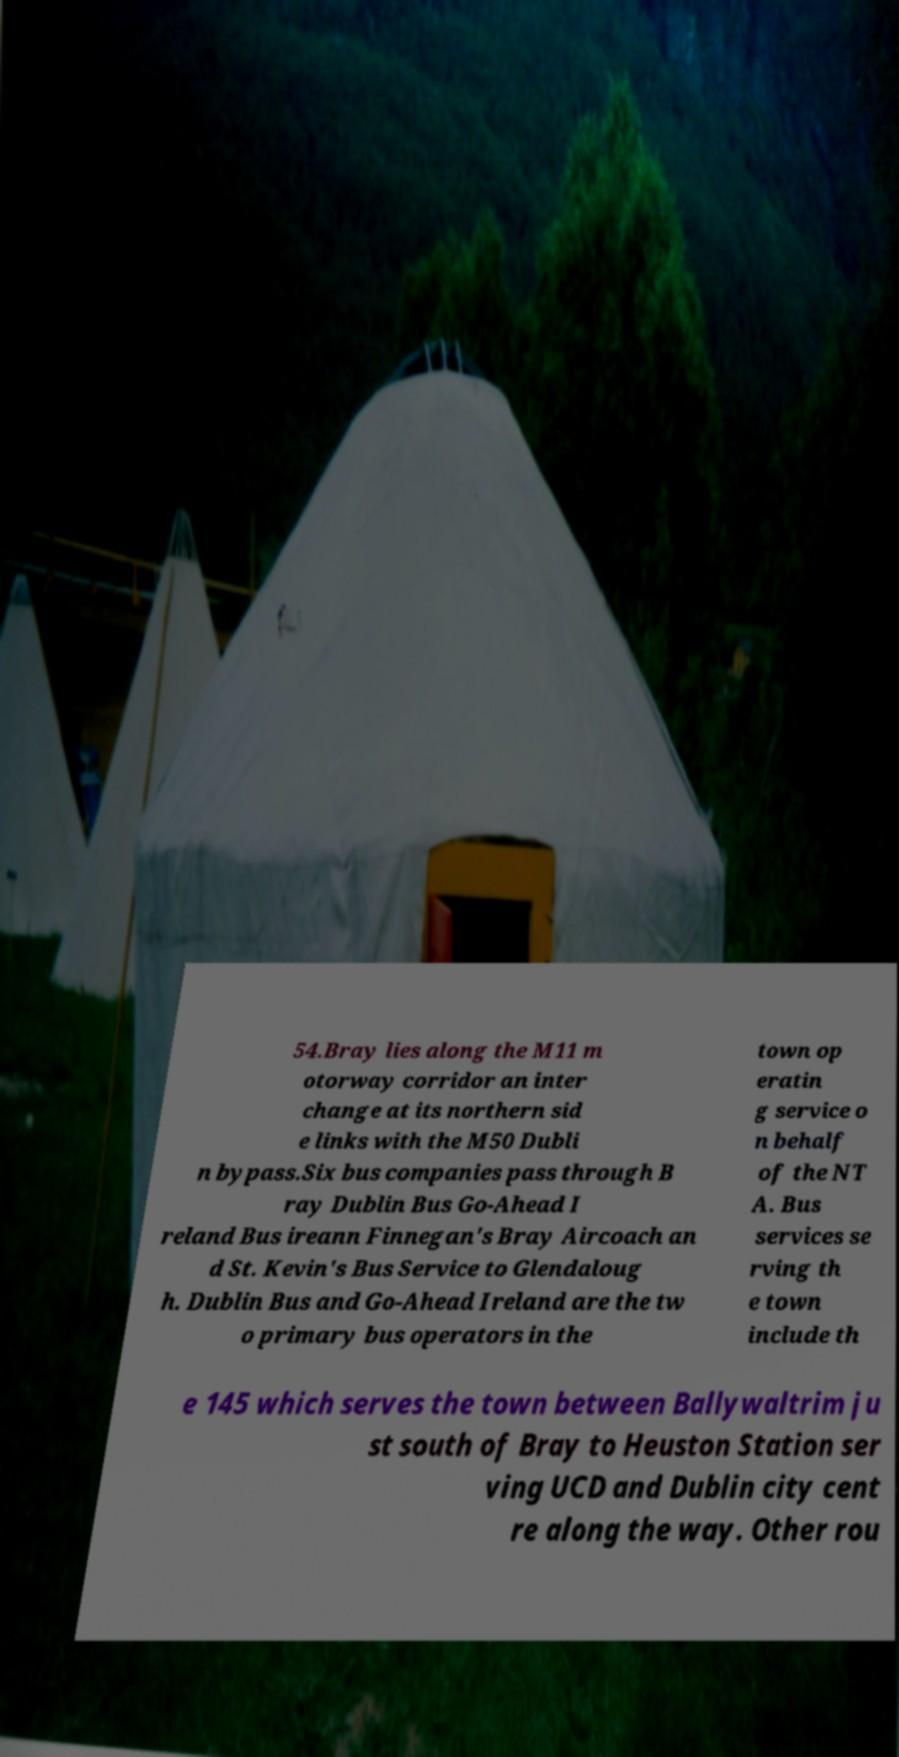Could you extract and type out the text from this image? 54.Bray lies along the M11 m otorway corridor an inter change at its northern sid e links with the M50 Dubli n bypass.Six bus companies pass through B ray Dublin Bus Go-Ahead I reland Bus ireann Finnegan's Bray Aircoach an d St. Kevin's Bus Service to Glendaloug h. Dublin Bus and Go-Ahead Ireland are the tw o primary bus operators in the town op eratin g service o n behalf of the NT A. Bus services se rving th e town include th e 145 which serves the town between Ballywaltrim ju st south of Bray to Heuston Station ser ving UCD and Dublin city cent re along the way. Other rou 